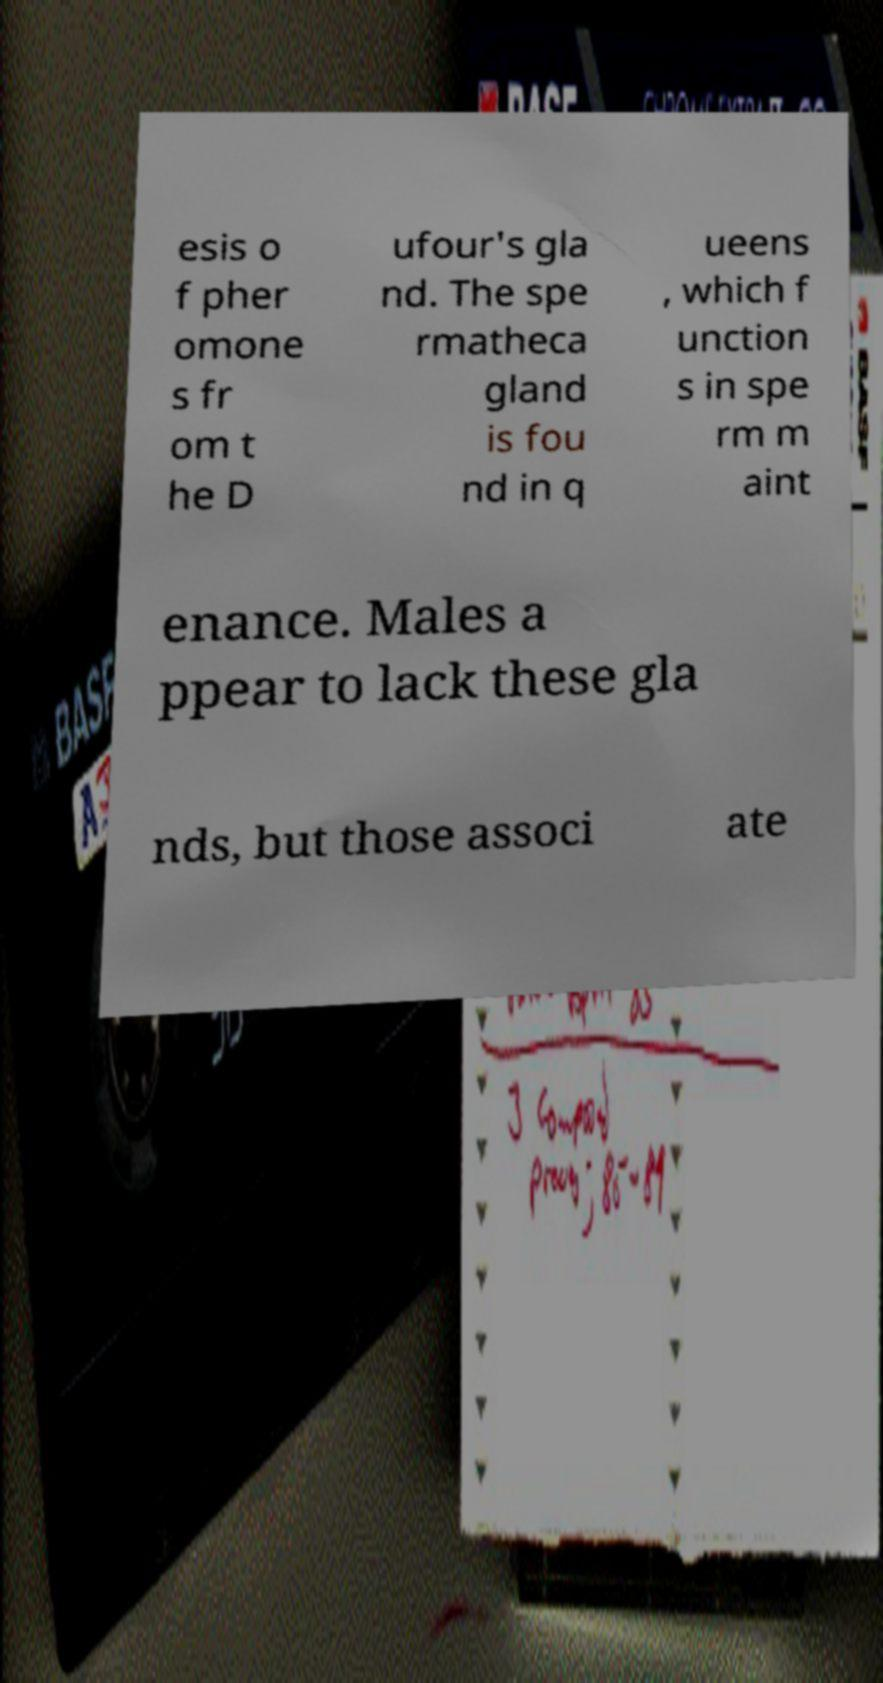Could you assist in decoding the text presented in this image and type it out clearly? esis o f pher omone s fr om t he D ufour's gla nd. The spe rmatheca gland is fou nd in q ueens , which f unction s in spe rm m aint enance. Males a ppear to lack these gla nds, but those associ ate 